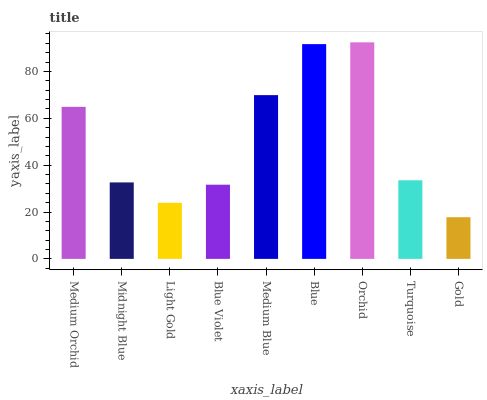Is Gold the minimum?
Answer yes or no. Yes. Is Orchid the maximum?
Answer yes or no. Yes. Is Midnight Blue the minimum?
Answer yes or no. No. Is Midnight Blue the maximum?
Answer yes or no. No. Is Medium Orchid greater than Midnight Blue?
Answer yes or no. Yes. Is Midnight Blue less than Medium Orchid?
Answer yes or no. Yes. Is Midnight Blue greater than Medium Orchid?
Answer yes or no. No. Is Medium Orchid less than Midnight Blue?
Answer yes or no. No. Is Turquoise the high median?
Answer yes or no. Yes. Is Turquoise the low median?
Answer yes or no. Yes. Is Orchid the high median?
Answer yes or no. No. Is Medium Blue the low median?
Answer yes or no. No. 